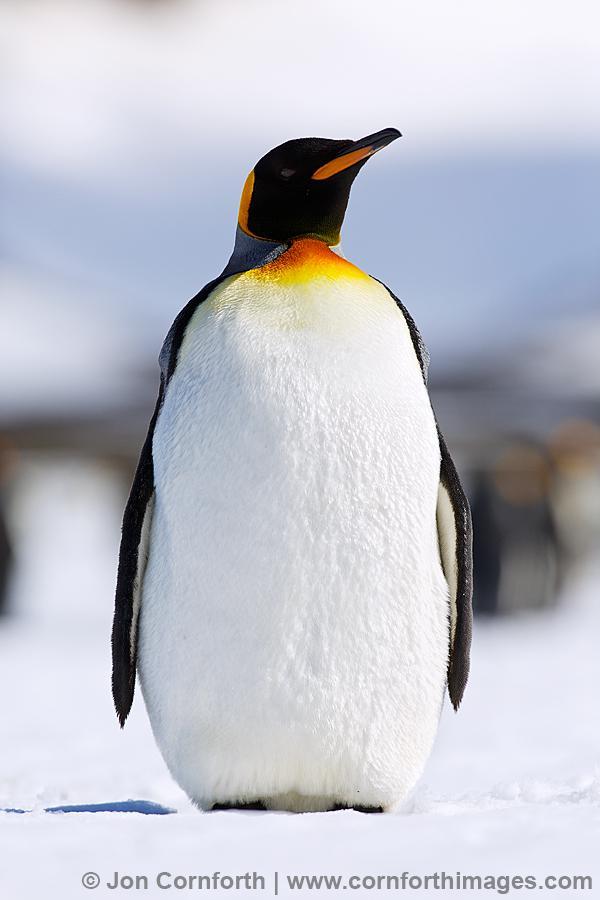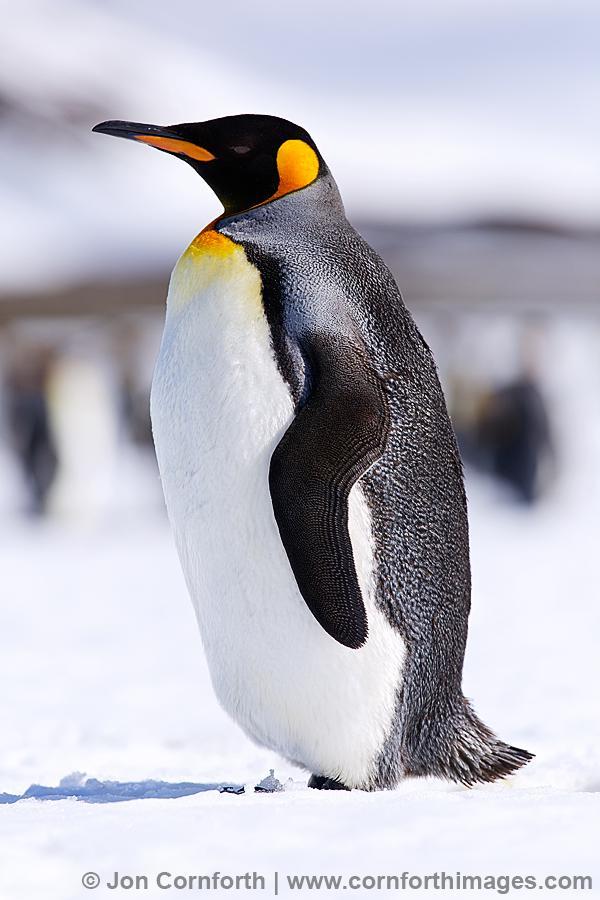The first image is the image on the left, the second image is the image on the right. For the images displayed, is the sentence "There are exactly two penguins." factually correct? Answer yes or no. Yes. The first image is the image on the left, the second image is the image on the right. Considering the images on both sides, is "There are two penguins" valid? Answer yes or no. Yes. The first image is the image on the left, the second image is the image on the right. Assess this claim about the two images: "In one image there are at least one penguin standing on rock.". Correct or not? Answer yes or no. No. 